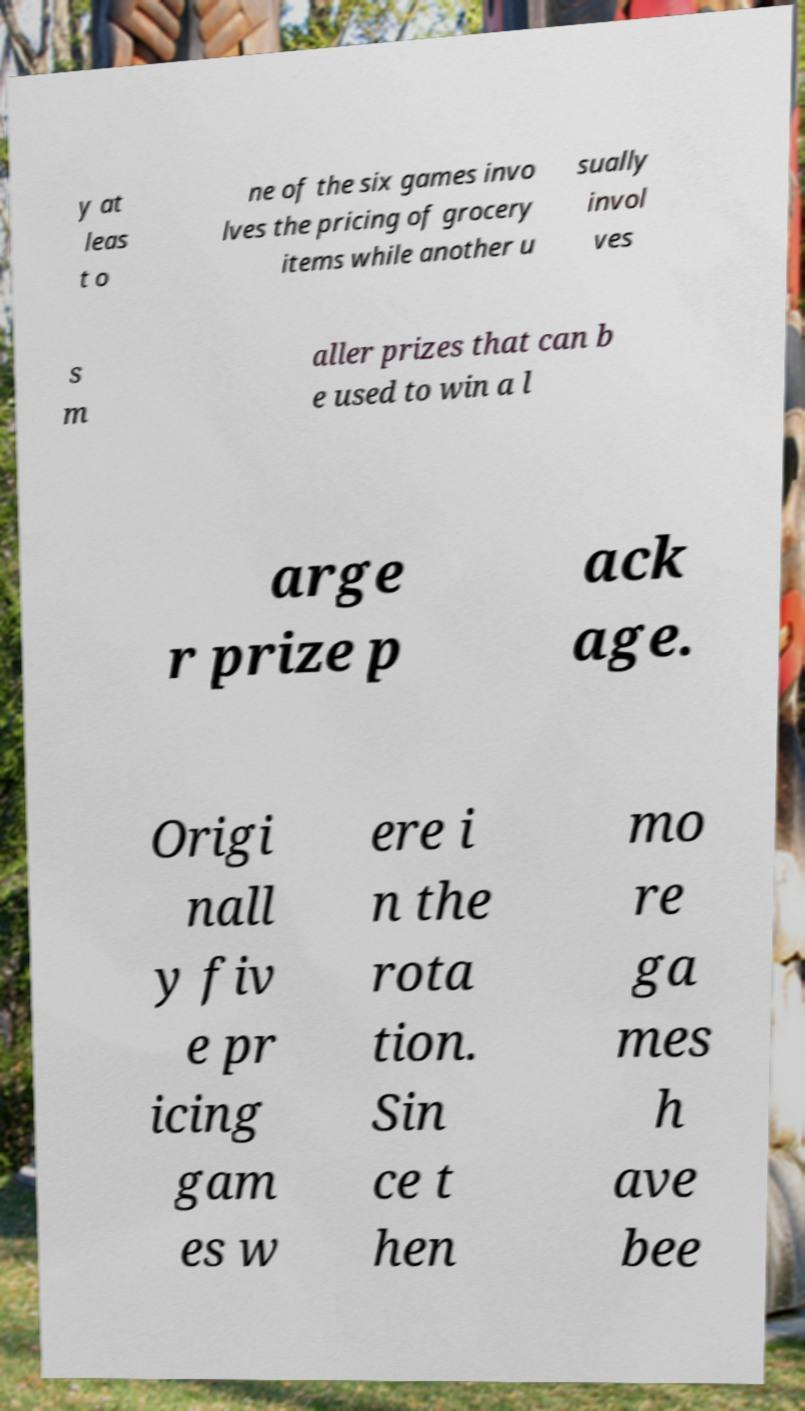Please identify and transcribe the text found in this image. y at leas t o ne of the six games invo lves the pricing of grocery items while another u sually invol ves s m aller prizes that can b e used to win a l arge r prize p ack age. Origi nall y fiv e pr icing gam es w ere i n the rota tion. Sin ce t hen mo re ga mes h ave bee 